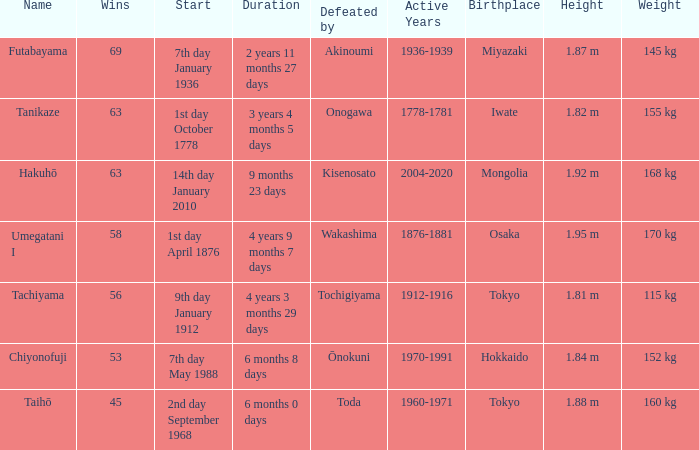How many wins were held before being defeated by toda? 1.0. 